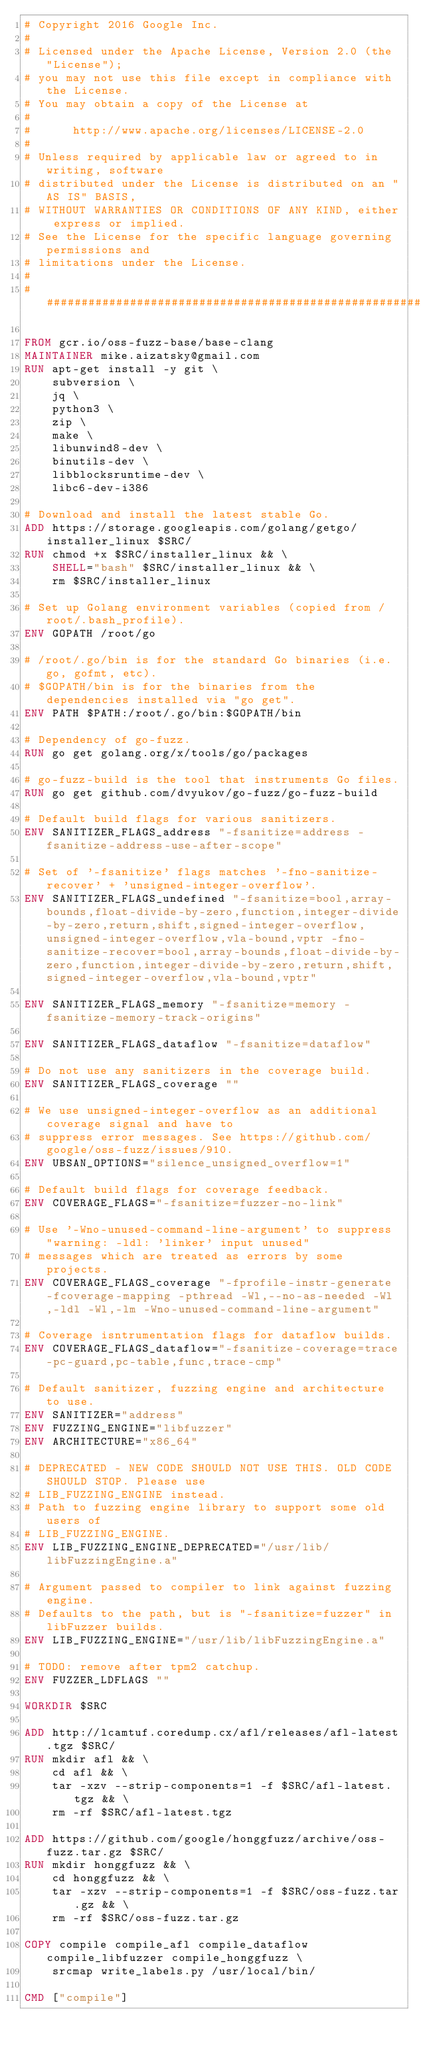<code> <loc_0><loc_0><loc_500><loc_500><_Dockerfile_># Copyright 2016 Google Inc.
#
# Licensed under the Apache License, Version 2.0 (the "License");
# you may not use this file except in compliance with the License.
# You may obtain a copy of the License at
#
#      http://www.apache.org/licenses/LICENSE-2.0
#
# Unless required by applicable law or agreed to in writing, software
# distributed under the License is distributed on an "AS IS" BASIS,
# WITHOUT WARRANTIES OR CONDITIONS OF ANY KIND, either express or implied.
# See the License for the specific language governing permissions and
# limitations under the License.
#
################################################################################

FROM gcr.io/oss-fuzz-base/base-clang
MAINTAINER mike.aizatsky@gmail.com
RUN apt-get install -y git \
    subversion \
    jq \
    python3 \
    zip \
    make \
    libunwind8-dev \
    binutils-dev \
    libblocksruntime-dev \
    libc6-dev-i386

# Download and install the latest stable Go.
ADD https://storage.googleapis.com/golang/getgo/installer_linux $SRC/
RUN chmod +x $SRC/installer_linux && \
    SHELL="bash" $SRC/installer_linux && \
    rm $SRC/installer_linux

# Set up Golang environment variables (copied from /root/.bash_profile).
ENV GOPATH /root/go

# /root/.go/bin is for the standard Go binaries (i.e. go, gofmt, etc).
# $GOPATH/bin is for the binaries from the dependencies installed via "go get".
ENV PATH $PATH:/root/.go/bin:$GOPATH/bin

# Dependency of go-fuzz.
RUN go get golang.org/x/tools/go/packages

# go-fuzz-build is the tool that instruments Go files.
RUN go get github.com/dvyukov/go-fuzz/go-fuzz-build

# Default build flags for various sanitizers.
ENV SANITIZER_FLAGS_address "-fsanitize=address -fsanitize-address-use-after-scope"

# Set of '-fsanitize' flags matches '-fno-sanitize-recover' + 'unsigned-integer-overflow'.
ENV SANITIZER_FLAGS_undefined "-fsanitize=bool,array-bounds,float-divide-by-zero,function,integer-divide-by-zero,return,shift,signed-integer-overflow,unsigned-integer-overflow,vla-bound,vptr -fno-sanitize-recover=bool,array-bounds,float-divide-by-zero,function,integer-divide-by-zero,return,shift,signed-integer-overflow,vla-bound,vptr"

ENV SANITIZER_FLAGS_memory "-fsanitize=memory -fsanitize-memory-track-origins"

ENV SANITIZER_FLAGS_dataflow "-fsanitize=dataflow"

# Do not use any sanitizers in the coverage build.
ENV SANITIZER_FLAGS_coverage ""

# We use unsigned-integer-overflow as an additional coverage signal and have to
# suppress error messages. See https://github.com/google/oss-fuzz/issues/910.
ENV UBSAN_OPTIONS="silence_unsigned_overflow=1"

# Default build flags for coverage feedback.
ENV COVERAGE_FLAGS="-fsanitize=fuzzer-no-link"

# Use '-Wno-unused-command-line-argument' to suppress "warning: -ldl: 'linker' input unused"
# messages which are treated as errors by some projects.
ENV COVERAGE_FLAGS_coverage "-fprofile-instr-generate -fcoverage-mapping -pthread -Wl,--no-as-needed -Wl,-ldl -Wl,-lm -Wno-unused-command-line-argument"

# Coverage isntrumentation flags for dataflow builds.
ENV COVERAGE_FLAGS_dataflow="-fsanitize-coverage=trace-pc-guard,pc-table,func,trace-cmp"

# Default sanitizer, fuzzing engine and architecture to use.
ENV SANITIZER="address"
ENV FUZZING_ENGINE="libfuzzer"
ENV ARCHITECTURE="x86_64"

# DEPRECATED - NEW CODE SHOULD NOT USE THIS. OLD CODE SHOULD STOP. Please use
# LIB_FUZZING_ENGINE instead.
# Path to fuzzing engine library to support some old users of
# LIB_FUZZING_ENGINE.
ENV LIB_FUZZING_ENGINE_DEPRECATED="/usr/lib/libFuzzingEngine.a"

# Argument passed to compiler to link against fuzzing engine.
# Defaults to the path, but is "-fsanitize=fuzzer" in libFuzzer builds.
ENV LIB_FUZZING_ENGINE="/usr/lib/libFuzzingEngine.a"

# TODO: remove after tpm2 catchup.
ENV FUZZER_LDFLAGS ""

WORKDIR $SRC

ADD http://lcamtuf.coredump.cx/afl/releases/afl-latest.tgz $SRC/
RUN mkdir afl && \
    cd afl && \
    tar -xzv --strip-components=1 -f $SRC/afl-latest.tgz && \
    rm -rf $SRC/afl-latest.tgz

ADD https://github.com/google/honggfuzz/archive/oss-fuzz.tar.gz $SRC/
RUN mkdir honggfuzz && \
    cd honggfuzz && \
    tar -xzv --strip-components=1 -f $SRC/oss-fuzz.tar.gz && \
    rm -rf $SRC/oss-fuzz.tar.gz

COPY compile compile_afl compile_dataflow compile_libfuzzer compile_honggfuzz \
    srcmap write_labels.py /usr/local/bin/

CMD ["compile"]
</code> 